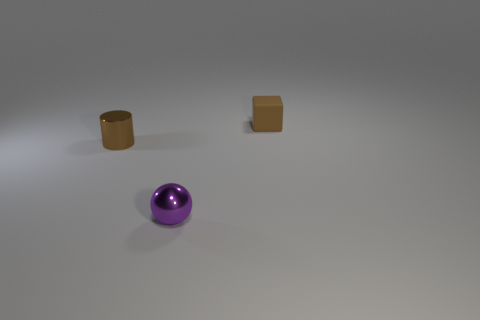Are there any other things that are made of the same material as the brown cube?
Ensure brevity in your answer.  No. The thing that is both in front of the tiny brown rubber block and right of the brown metal thing has what shape?
Your response must be concise. Sphere. Is the number of large cyan cylinders less than the number of brown cubes?
Your response must be concise. Yes. Is there a tiny sphere?
Make the answer very short. Yes. What number of other objects are the same size as the rubber thing?
Your answer should be compact. 2. Is the material of the tiny ball the same as the brown thing in front of the small brown rubber cube?
Ensure brevity in your answer.  Yes. Is the number of small blocks that are in front of the small brown metallic object the same as the number of brown shiny cylinders that are in front of the small brown cube?
Offer a terse response. No. What material is the tiny brown block?
Your answer should be compact. Rubber. There is a cylinder that is the same size as the metal ball; what color is it?
Provide a short and direct response. Brown. There is a small metal thing right of the cylinder; is there a brown block that is in front of it?
Provide a short and direct response. No. 